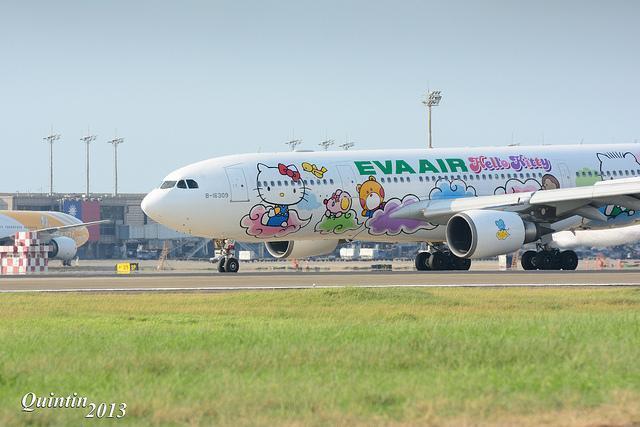How many airplanes are in the photo?
Give a very brief answer. 2. How many people have beards?
Give a very brief answer. 0. 